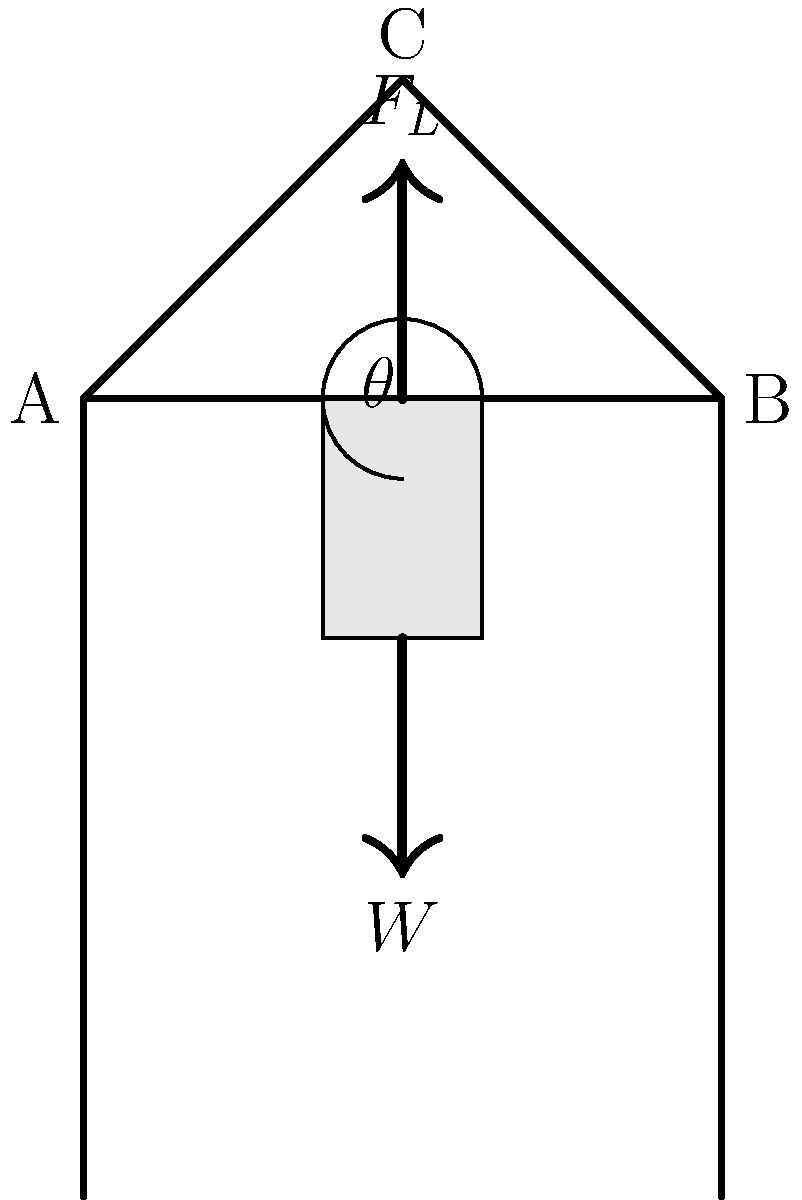A patient lifting device is shown in the diagram. The patient's weight $W$ is 800 N, and the angle $\theta$ between the horizontal and the lifting arm is 30°. Calculate the magnitude of the lifting force $F_L$ required to keep the patient stationary, assuming the system is in equilibrium. To solve this problem, we'll use the principles of statics and resolve forces in the vertical direction:

1) In equilibrium, the sum of all forces must equal zero.

2) The vertical components of the forces must balance:
   $F_L \cos \theta - W = 0$

3) We know:
   $W = 800$ N
   $\theta = 30°$

4) Substitute these values into the equation:
   $F_L \cos 30° - 800 = 0$

5) Solve for $F_L$:
   $F_L \cos 30° = 800$
   $F_L = \frac{800}{\cos 30°}$

6) Calculate:
   $F_L = \frac{800}{\cos 30°} = \frac{800}{0.866} \approx 923.8$ N

Therefore, the lifting force $F_L$ required to keep the patient stationary is approximately 923.8 N.
Answer: $F_L \approx 923.8$ N 